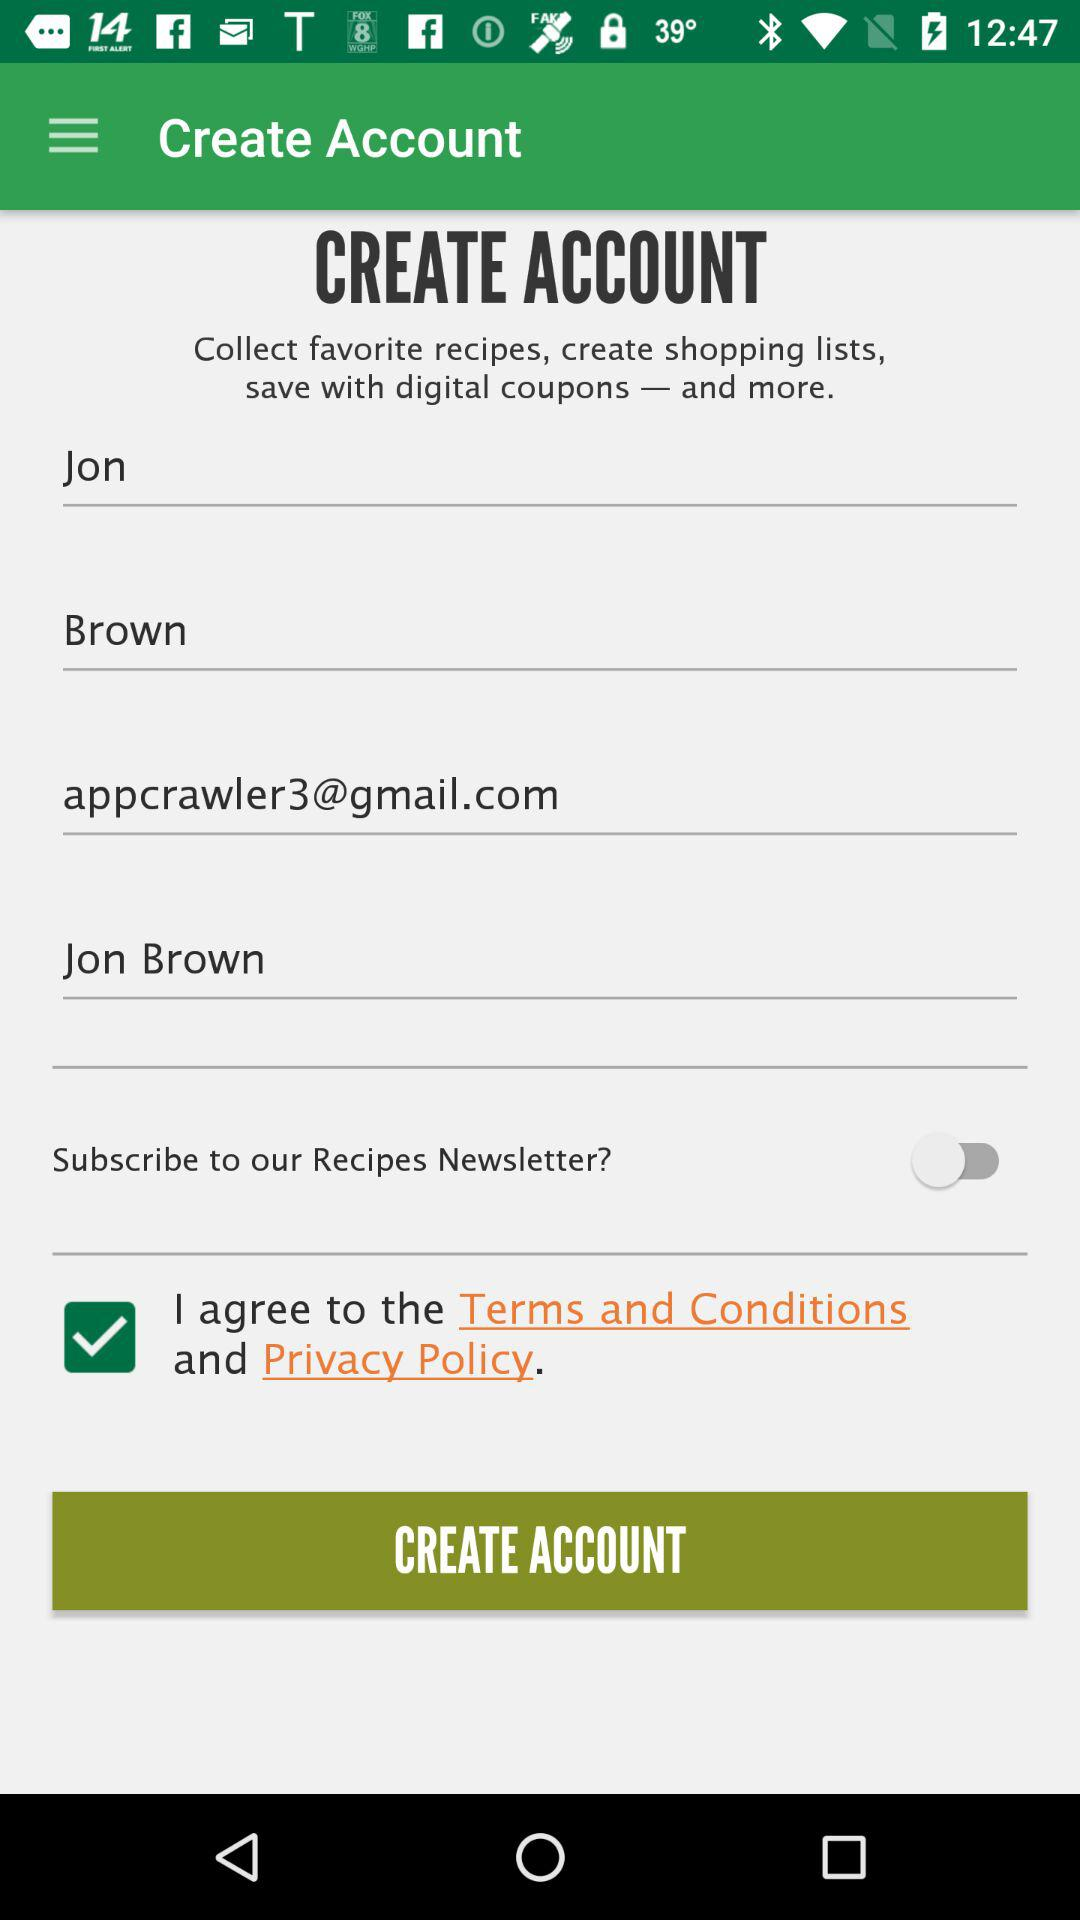What is the status of the subscribe to our recipes newsletter setting? The status is off. 